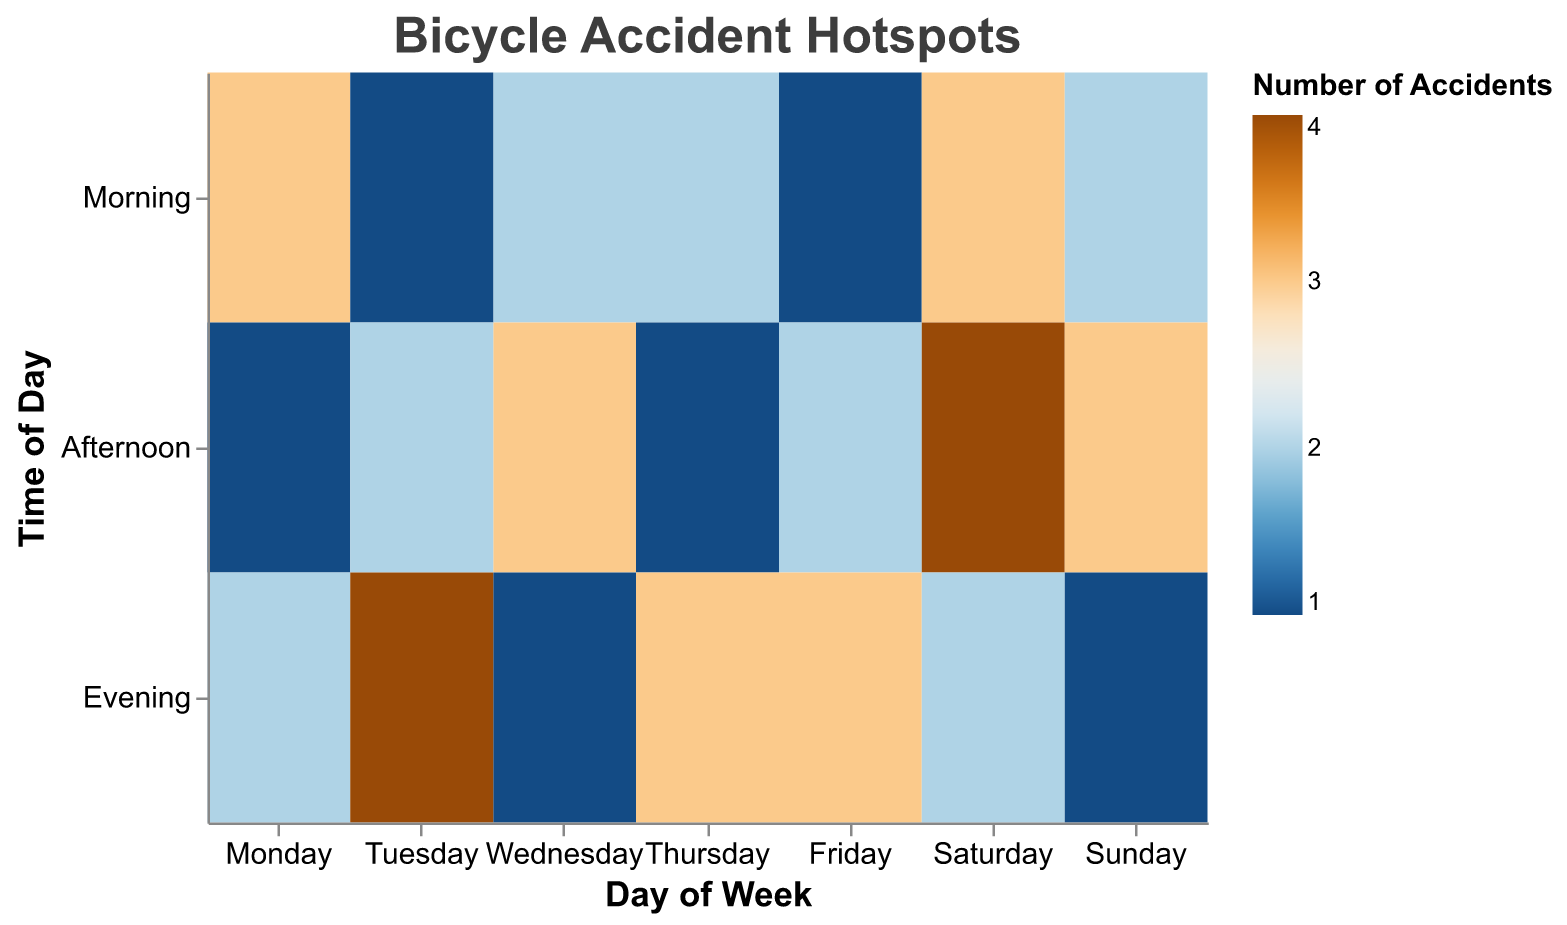What is the title of the heatmap? The title is displayed at the top of the figure.
Answer: Bicycle Accident Hotspots Which time of day has the most accidents at Main St & 3rd Ave on Monday? Look at "Main St & 3rd Ave" and "Monday", then find the time with the highest accident count. In this case, "Morning" has the darkest color, indicating the highest number of accidents (3).
Answer: Morning How many accidents occurred at Elm St & 5th Ave on Friday in the Evening? Focus on "Elm St & 5th Ave", "Friday", and "Evening". The corresponding value is "3".
Answer: 3 During which time of day do the most accidents occur on Saturday at Elm St & 5th Ave? Select "Elm St & 5th Ave", "Saturday", and compare the number of accidents across different times of the day. "Afternoon" has the highest value (4).
Answer: Afternoon Which location and time of day on Tuesday has the highest number of accidents? Check "Tuesday" and compare the accident counts for different locations and times of the day. "Park Blvd & 7th Ave" in the "Evening" has the highest number (4).
Answer: Park Blvd & 7th Ave, Evening What is the total number of accidents occurring at Park Blvd & 7th Ave on Thursday? Add the number of accidents for "Morning", "Afternoon", and "Evening" on "Thursday" for "Park Blvd & 7th Ave". \(2 (Morning) + 1 (Afternoon) + 3 (Evening) = 6\).
Answer: 6 Which day of the week has the most accidents at Oak St & 2nd Ave? Sum the number of accidents across different times of the day for each day. Oak St & 2nd Ave only appears on "Sunday", so sum for "Sunday": \(2 (Morning) + 3 (Afternoon) + 1 (Evening) = 6\).
Answer: Sunday Which location-time of day combination on Wednesday has the fewest accidents? Compare the accident counts for each time of day on "Wednesday" at "Main St & 3rd Ave". The "Evening" has the fewest accidents (1).
Answer: Main St & 3rd Ave, Evening 